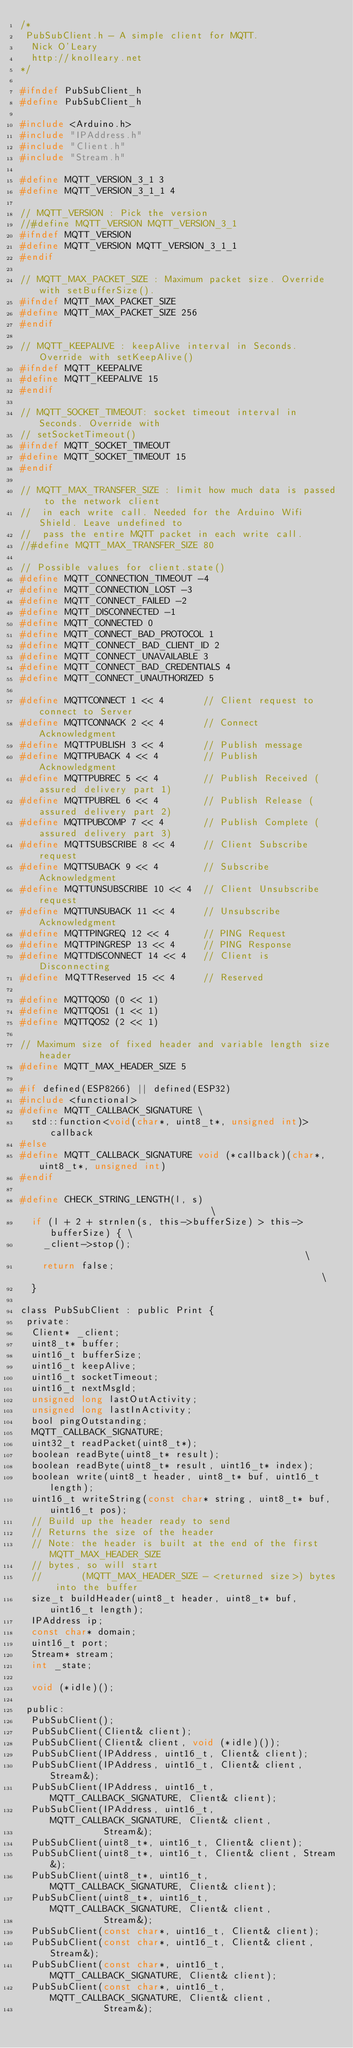<code> <loc_0><loc_0><loc_500><loc_500><_C_>/*
 PubSubClient.h - A simple client for MQTT.
  Nick O'Leary
  http://knolleary.net
*/

#ifndef PubSubClient_h
#define PubSubClient_h

#include <Arduino.h>
#include "IPAddress.h"
#include "Client.h"
#include "Stream.h"

#define MQTT_VERSION_3_1 3
#define MQTT_VERSION_3_1_1 4

// MQTT_VERSION : Pick the version
//#define MQTT_VERSION MQTT_VERSION_3_1
#ifndef MQTT_VERSION
#define MQTT_VERSION MQTT_VERSION_3_1_1
#endif

// MQTT_MAX_PACKET_SIZE : Maximum packet size. Override with setBufferSize().
#ifndef MQTT_MAX_PACKET_SIZE
#define MQTT_MAX_PACKET_SIZE 256
#endif

// MQTT_KEEPALIVE : keepAlive interval in Seconds. Override with setKeepAlive()
#ifndef MQTT_KEEPALIVE
#define MQTT_KEEPALIVE 15
#endif

// MQTT_SOCKET_TIMEOUT: socket timeout interval in Seconds. Override with
// setSocketTimeout()
#ifndef MQTT_SOCKET_TIMEOUT
#define MQTT_SOCKET_TIMEOUT 15
#endif

// MQTT_MAX_TRANSFER_SIZE : limit how much data is passed to the network client
//  in each write call. Needed for the Arduino Wifi Shield. Leave undefined to
//  pass the entire MQTT packet in each write call.
//#define MQTT_MAX_TRANSFER_SIZE 80

// Possible values for client.state()
#define MQTT_CONNECTION_TIMEOUT -4
#define MQTT_CONNECTION_LOST -3
#define MQTT_CONNECT_FAILED -2
#define MQTT_DISCONNECTED -1
#define MQTT_CONNECTED 0
#define MQTT_CONNECT_BAD_PROTOCOL 1
#define MQTT_CONNECT_BAD_CLIENT_ID 2
#define MQTT_CONNECT_UNAVAILABLE 3
#define MQTT_CONNECT_BAD_CREDENTIALS 4
#define MQTT_CONNECT_UNAUTHORIZED 5

#define MQTTCONNECT 1 << 4       // Client request to connect to Server
#define MQTTCONNACK 2 << 4       // Connect Acknowledgment
#define MQTTPUBLISH 3 << 4       // Publish message
#define MQTTPUBACK 4 << 4        // Publish Acknowledgment
#define MQTTPUBREC 5 << 4        // Publish Received (assured delivery part 1)
#define MQTTPUBREL 6 << 4        // Publish Release (assured delivery part 2)
#define MQTTPUBCOMP 7 << 4       // Publish Complete (assured delivery part 3)
#define MQTTSUBSCRIBE 8 << 4     // Client Subscribe request
#define MQTTSUBACK 9 << 4        // Subscribe Acknowledgment
#define MQTTUNSUBSCRIBE 10 << 4  // Client Unsubscribe request
#define MQTTUNSUBACK 11 << 4     // Unsubscribe Acknowledgment
#define MQTTPINGREQ 12 << 4      // PING Request
#define MQTTPINGRESP 13 << 4     // PING Response
#define MQTTDISCONNECT 14 << 4   // Client is Disconnecting
#define MQTTReserved 15 << 4     // Reserved

#define MQTTQOS0 (0 << 1)
#define MQTTQOS1 (1 << 1)
#define MQTTQOS2 (2 << 1)

// Maximum size of fixed header and variable length size header
#define MQTT_MAX_HEADER_SIZE 5

#if defined(ESP8266) || defined(ESP32)
#include <functional>
#define MQTT_CALLBACK_SIGNATURE \
  std::function<void(char*, uint8_t*, unsigned int)> callback
#else
#define MQTT_CALLBACK_SIGNATURE void (*callback)(char*, uint8_t*, unsigned int)
#endif

#define CHECK_STRING_LENGTH(l, s)                                \
  if (l + 2 + strnlen(s, this->bufferSize) > this->bufferSize) { \
    _client->stop();                                             \
    return false;                                                \
  }

class PubSubClient : public Print {
 private:
  Client* _client;
  uint8_t* buffer;
  uint16_t bufferSize;
  uint16_t keepAlive;
  uint16_t socketTimeout;
  uint16_t nextMsgId;
  unsigned long lastOutActivity;
  unsigned long lastInActivity;
  bool pingOutstanding;
  MQTT_CALLBACK_SIGNATURE;
  uint32_t readPacket(uint8_t*);
  boolean readByte(uint8_t* result);
  boolean readByte(uint8_t* result, uint16_t* index);
  boolean write(uint8_t header, uint8_t* buf, uint16_t length);
  uint16_t writeString(const char* string, uint8_t* buf, uint16_t pos);
  // Build up the header ready to send
  // Returns the size of the header
  // Note: the header is built at the end of the first MQTT_MAX_HEADER_SIZE
  // bytes, so will start
  //       (MQTT_MAX_HEADER_SIZE - <returned size>) bytes into the buffer
  size_t buildHeader(uint8_t header, uint8_t* buf, uint16_t length);
  IPAddress ip;
  const char* domain;
  uint16_t port;
  Stream* stream;
  int _state;

  void (*idle)();

 public:
  PubSubClient();
  PubSubClient(Client& client);
  PubSubClient(Client& client, void (*idle)());
  PubSubClient(IPAddress, uint16_t, Client& client);
  PubSubClient(IPAddress, uint16_t, Client& client, Stream&);
  PubSubClient(IPAddress, uint16_t, MQTT_CALLBACK_SIGNATURE, Client& client);
  PubSubClient(IPAddress, uint16_t, MQTT_CALLBACK_SIGNATURE, Client& client,
               Stream&);
  PubSubClient(uint8_t*, uint16_t, Client& client);
  PubSubClient(uint8_t*, uint16_t, Client& client, Stream&);
  PubSubClient(uint8_t*, uint16_t, MQTT_CALLBACK_SIGNATURE, Client& client);
  PubSubClient(uint8_t*, uint16_t, MQTT_CALLBACK_SIGNATURE, Client& client,
               Stream&);
  PubSubClient(const char*, uint16_t, Client& client);
  PubSubClient(const char*, uint16_t, Client& client, Stream&);
  PubSubClient(const char*, uint16_t, MQTT_CALLBACK_SIGNATURE, Client& client);
  PubSubClient(const char*, uint16_t, MQTT_CALLBACK_SIGNATURE, Client& client,
               Stream&);
</code> 